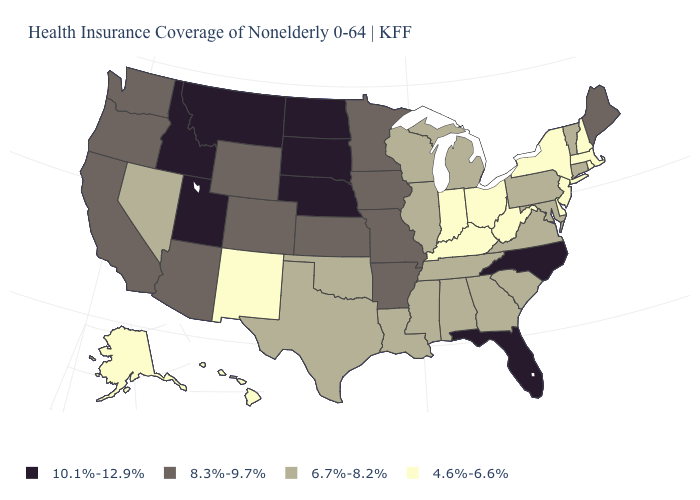What is the lowest value in the West?
Give a very brief answer. 4.6%-6.6%. What is the value of Connecticut?
Short answer required. 6.7%-8.2%. What is the value of Oklahoma?
Be succinct. 6.7%-8.2%. What is the value of Wyoming?
Keep it brief. 8.3%-9.7%. What is the value of Mississippi?
Keep it brief. 6.7%-8.2%. What is the value of Iowa?
Write a very short answer. 8.3%-9.7%. Which states hav the highest value in the Northeast?
Concise answer only. Maine. Does the first symbol in the legend represent the smallest category?
Write a very short answer. No. Name the states that have a value in the range 4.6%-6.6%?
Short answer required. Alaska, Delaware, Hawaii, Indiana, Kentucky, Massachusetts, New Hampshire, New Jersey, New Mexico, New York, Ohio, Rhode Island, West Virginia. Name the states that have a value in the range 4.6%-6.6%?
Answer briefly. Alaska, Delaware, Hawaii, Indiana, Kentucky, Massachusetts, New Hampshire, New Jersey, New Mexico, New York, Ohio, Rhode Island, West Virginia. Which states have the highest value in the USA?
Write a very short answer. Florida, Idaho, Montana, Nebraska, North Carolina, North Dakota, South Dakota, Utah. Which states have the lowest value in the USA?
Be succinct. Alaska, Delaware, Hawaii, Indiana, Kentucky, Massachusetts, New Hampshire, New Jersey, New Mexico, New York, Ohio, Rhode Island, West Virginia. Among the states that border Connecticut , which have the lowest value?
Write a very short answer. Massachusetts, New York, Rhode Island. Which states have the lowest value in the South?
Give a very brief answer. Delaware, Kentucky, West Virginia. Name the states that have a value in the range 4.6%-6.6%?
Concise answer only. Alaska, Delaware, Hawaii, Indiana, Kentucky, Massachusetts, New Hampshire, New Jersey, New Mexico, New York, Ohio, Rhode Island, West Virginia. 